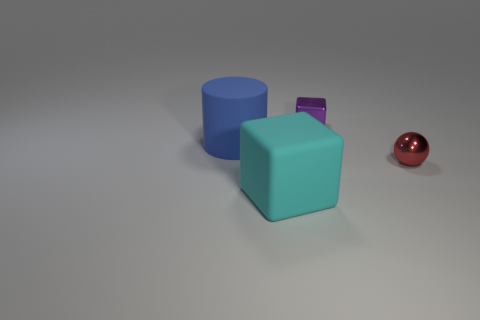There is a large rubber object that is the same shape as the tiny purple thing; what is its color?
Keep it short and to the point. Cyan. What is the size of the purple shiny thing that is the same shape as the large cyan rubber object?
Provide a short and direct response. Small. How many small purple objects have the same material as the blue cylinder?
Make the answer very short. 0. There is a small metallic thing to the right of the tiny purple thing on the right side of the big cylinder; is there a tiny red metallic sphere that is left of it?
Ensure brevity in your answer.  No. What shape is the small purple metal thing?
Make the answer very short. Cube. Is the big object right of the blue cylinder made of the same material as the small thing that is right of the small purple metallic object?
Your answer should be very brief. No. What number of cylinders have the same color as the sphere?
Your response must be concise. 0. There is a thing that is in front of the large blue rubber object and on the left side of the red thing; what shape is it?
Provide a short and direct response. Cube. What is the color of the thing that is both in front of the small purple object and behind the tiny ball?
Keep it short and to the point. Blue. Is the number of purple objects right of the large cyan matte object greater than the number of red things behind the tiny red object?
Offer a very short reply. Yes. 